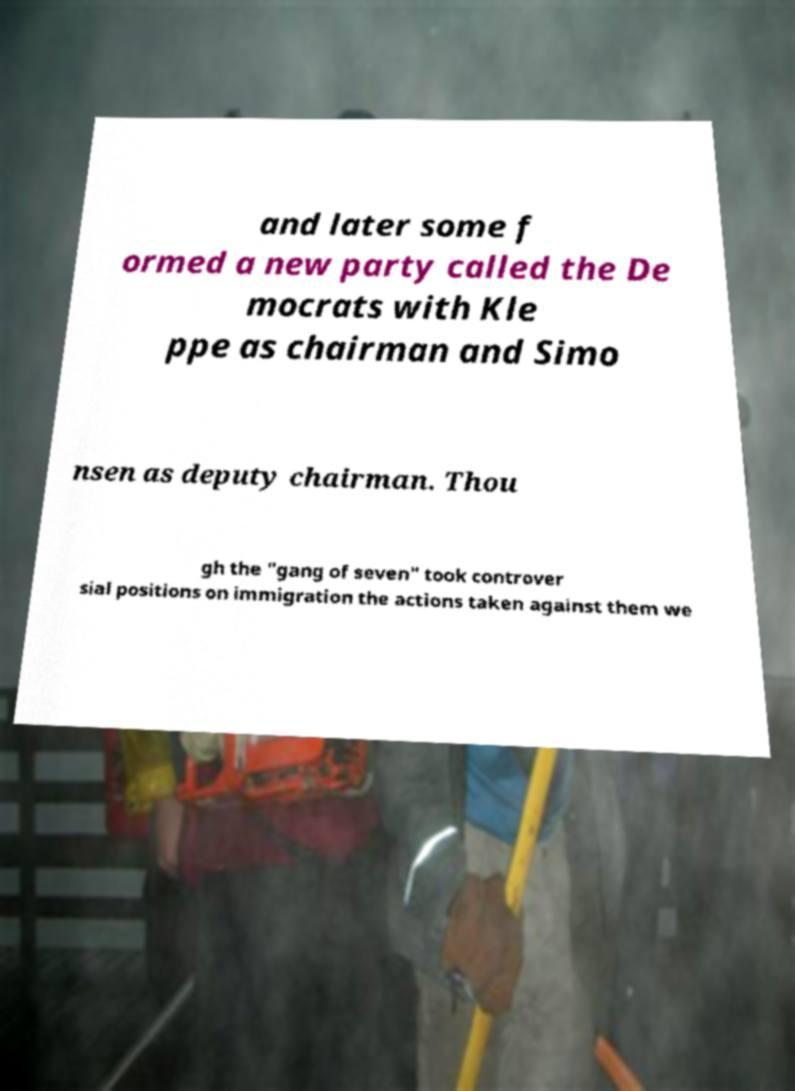What messages or text are displayed in this image? I need them in a readable, typed format. and later some f ormed a new party called the De mocrats with Kle ppe as chairman and Simo nsen as deputy chairman. Thou gh the "gang of seven" took controver sial positions on immigration the actions taken against them we 